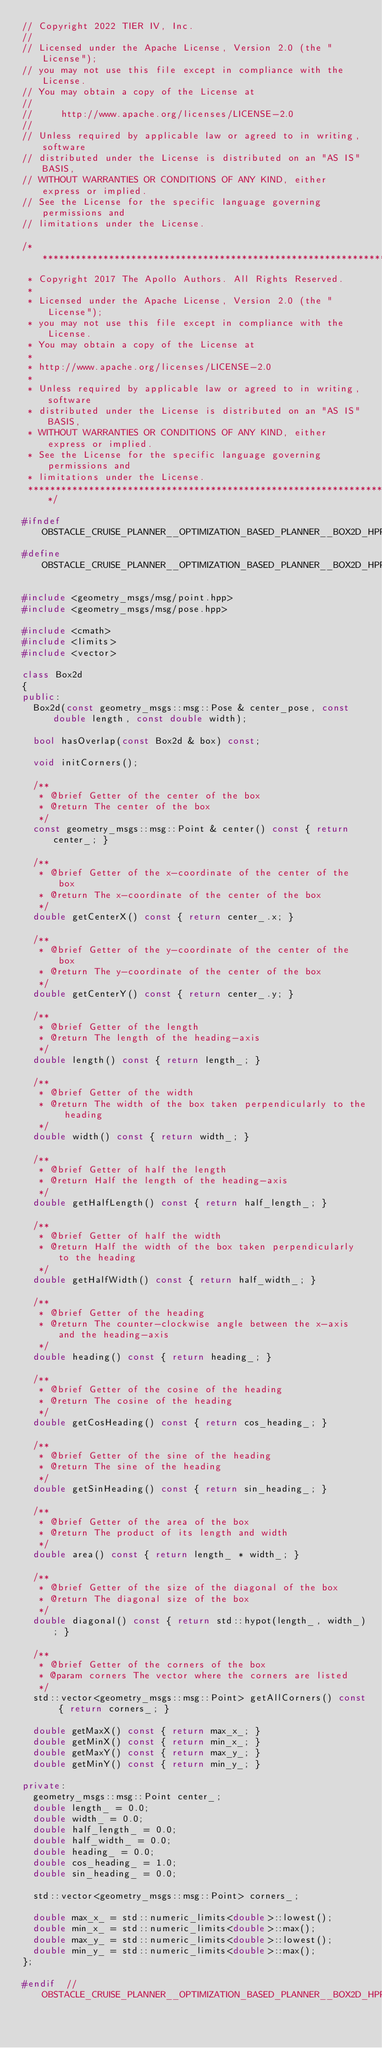<code> <loc_0><loc_0><loc_500><loc_500><_C++_>// Copyright 2022 TIER IV, Inc.
//
// Licensed under the Apache License, Version 2.0 (the "License");
// you may not use this file except in compliance with the License.
// You may obtain a copy of the License at
//
//     http://www.apache.org/licenses/LICENSE-2.0
//
// Unless required by applicable law or agreed to in writing, software
// distributed under the License is distributed on an "AS IS" BASIS,
// WITHOUT WARRANTIES OR CONDITIONS OF ANY KIND, either express or implied.
// See the License for the specific language governing permissions and
// limitations under the License.

/******************************************************************************
 * Copyright 2017 The Apollo Authors. All Rights Reserved.
 *
 * Licensed under the Apache License, Version 2.0 (the "License");
 * you may not use this file except in compliance with the License.
 * You may obtain a copy of the License at
 *
 * http://www.apache.org/licenses/LICENSE-2.0
 *
 * Unless required by applicable law or agreed to in writing, software
 * distributed under the License is distributed on an "AS IS" BASIS,
 * WITHOUT WARRANTIES OR CONDITIONS OF ANY KIND, either express or implied.
 * See the License for the specific language governing permissions and
 * limitations under the License.
 *****************************************************************************/

#ifndef OBSTACLE_CRUISE_PLANNER__OPTIMIZATION_BASED_PLANNER__BOX2D_HPP_
#define OBSTACLE_CRUISE_PLANNER__OPTIMIZATION_BASED_PLANNER__BOX2D_HPP_

#include <geometry_msgs/msg/point.hpp>
#include <geometry_msgs/msg/pose.hpp>

#include <cmath>
#include <limits>
#include <vector>

class Box2d
{
public:
  Box2d(const geometry_msgs::msg::Pose & center_pose, const double length, const double width);

  bool hasOverlap(const Box2d & box) const;

  void initCorners();

  /**
   * @brief Getter of the center of the box
   * @return The center of the box
   */
  const geometry_msgs::msg::Point & center() const { return center_; }

  /**
   * @brief Getter of the x-coordinate of the center of the box
   * @return The x-coordinate of the center of the box
   */
  double getCenterX() const { return center_.x; }

  /**
   * @brief Getter of the y-coordinate of the center of the box
   * @return The y-coordinate of the center of the box
   */
  double getCenterY() const { return center_.y; }

  /**
   * @brief Getter of the length
   * @return The length of the heading-axis
   */
  double length() const { return length_; }

  /**
   * @brief Getter of the width
   * @return The width of the box taken perpendicularly to the heading
   */
  double width() const { return width_; }

  /**
   * @brief Getter of half the length
   * @return Half the length of the heading-axis
   */
  double getHalfLength() const { return half_length_; }

  /**
   * @brief Getter of half the width
   * @return Half the width of the box taken perpendicularly to the heading
   */
  double getHalfWidth() const { return half_width_; }

  /**
   * @brief Getter of the heading
   * @return The counter-clockwise angle between the x-axis and the heading-axis
   */
  double heading() const { return heading_; }

  /**
   * @brief Getter of the cosine of the heading
   * @return The cosine of the heading
   */
  double getCosHeading() const { return cos_heading_; }

  /**
   * @brief Getter of the sine of the heading
   * @return The sine of the heading
   */
  double getSinHeading() const { return sin_heading_; }

  /**
   * @brief Getter of the area of the box
   * @return The product of its length and width
   */
  double area() const { return length_ * width_; }

  /**
   * @brief Getter of the size of the diagonal of the box
   * @return The diagonal size of the box
   */
  double diagonal() const { return std::hypot(length_, width_); }

  /**
   * @brief Getter of the corners of the box
   * @param corners The vector where the corners are listed
   */
  std::vector<geometry_msgs::msg::Point> getAllCorners() const { return corners_; }

  double getMaxX() const { return max_x_; }
  double getMinX() const { return min_x_; }
  double getMaxY() const { return max_y_; }
  double getMinY() const { return min_y_; }

private:
  geometry_msgs::msg::Point center_;
  double length_ = 0.0;
  double width_ = 0.0;
  double half_length_ = 0.0;
  double half_width_ = 0.0;
  double heading_ = 0.0;
  double cos_heading_ = 1.0;
  double sin_heading_ = 0.0;

  std::vector<geometry_msgs::msg::Point> corners_;

  double max_x_ = std::numeric_limits<double>::lowest();
  double min_x_ = std::numeric_limits<double>::max();
  double max_y_ = std::numeric_limits<double>::lowest();
  double min_y_ = std::numeric_limits<double>::max();
};

#endif  // OBSTACLE_CRUISE_PLANNER__OPTIMIZATION_BASED_PLANNER__BOX2D_HPP_
</code> 